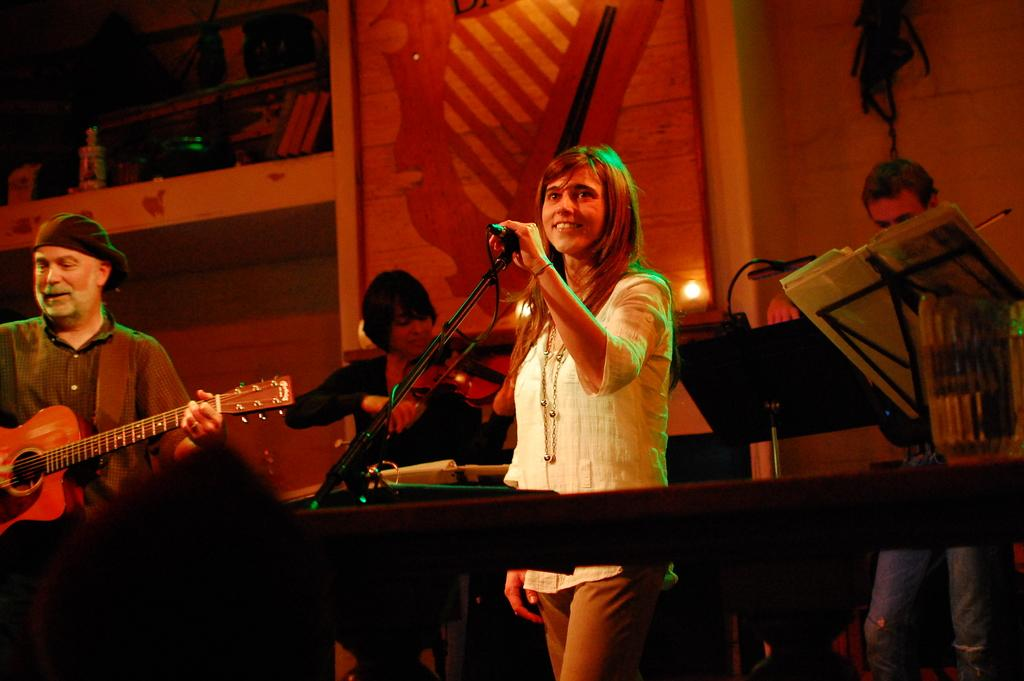What is present in the background of the image? There is a wall in the image. What are the people in the image doing? The people are playing musical instruments. Can you describe the activities of the people in the image? The people are playing musical instruments, which suggests they might be in a band or performing for an audience. What type of property is being sold in the image? There is no property being sold in the image; it features people playing musical instruments in front of a wall. What record is being broken by the people in the image? There is no record being broken in the image; it simply shows people playing musical instruments. 